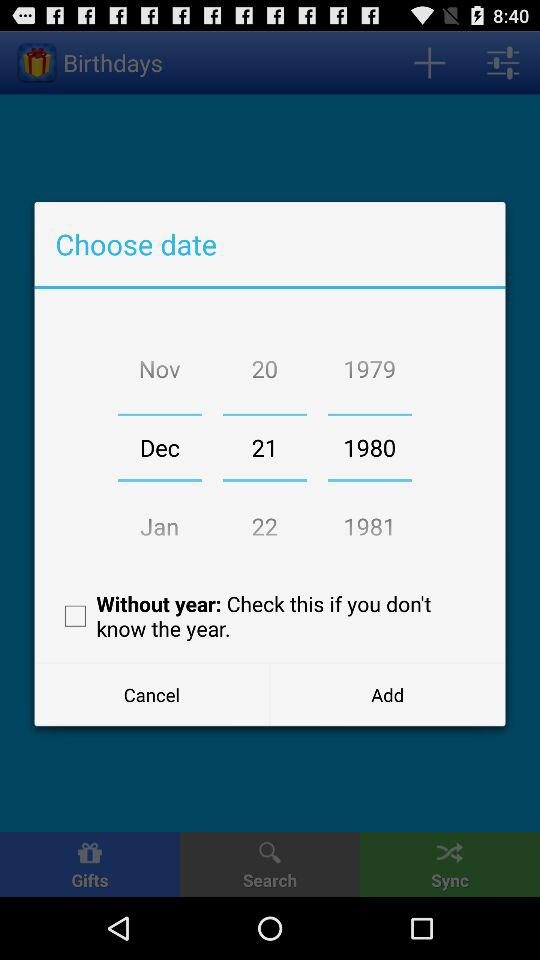What's the chosen date? The chosen date is December 21, 1980. 